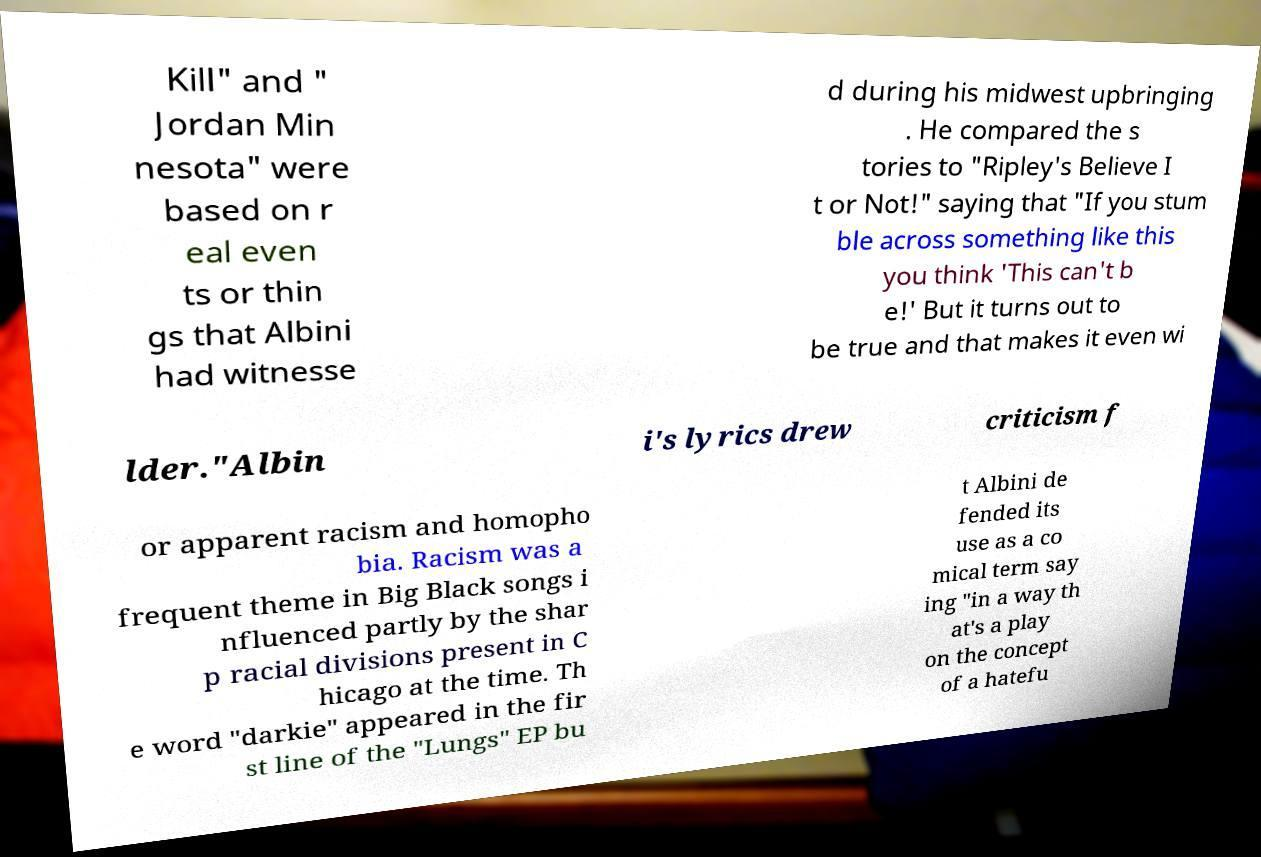There's text embedded in this image that I need extracted. Can you transcribe it verbatim? Kill" and " Jordan Min nesota" were based on r eal even ts or thin gs that Albini had witnesse d during his midwest upbringing . He compared the s tories to "Ripley's Believe I t or Not!" saying that "If you stum ble across something like this you think 'This can't b e!' But it turns out to be true and that makes it even wi lder."Albin i's lyrics drew criticism f or apparent racism and homopho bia. Racism was a frequent theme in Big Black songs i nfluenced partly by the shar p racial divisions present in C hicago at the time. Th e word "darkie" appeared in the fir st line of the "Lungs" EP bu t Albini de fended its use as a co mical term say ing "in a way th at's a play on the concept of a hatefu 